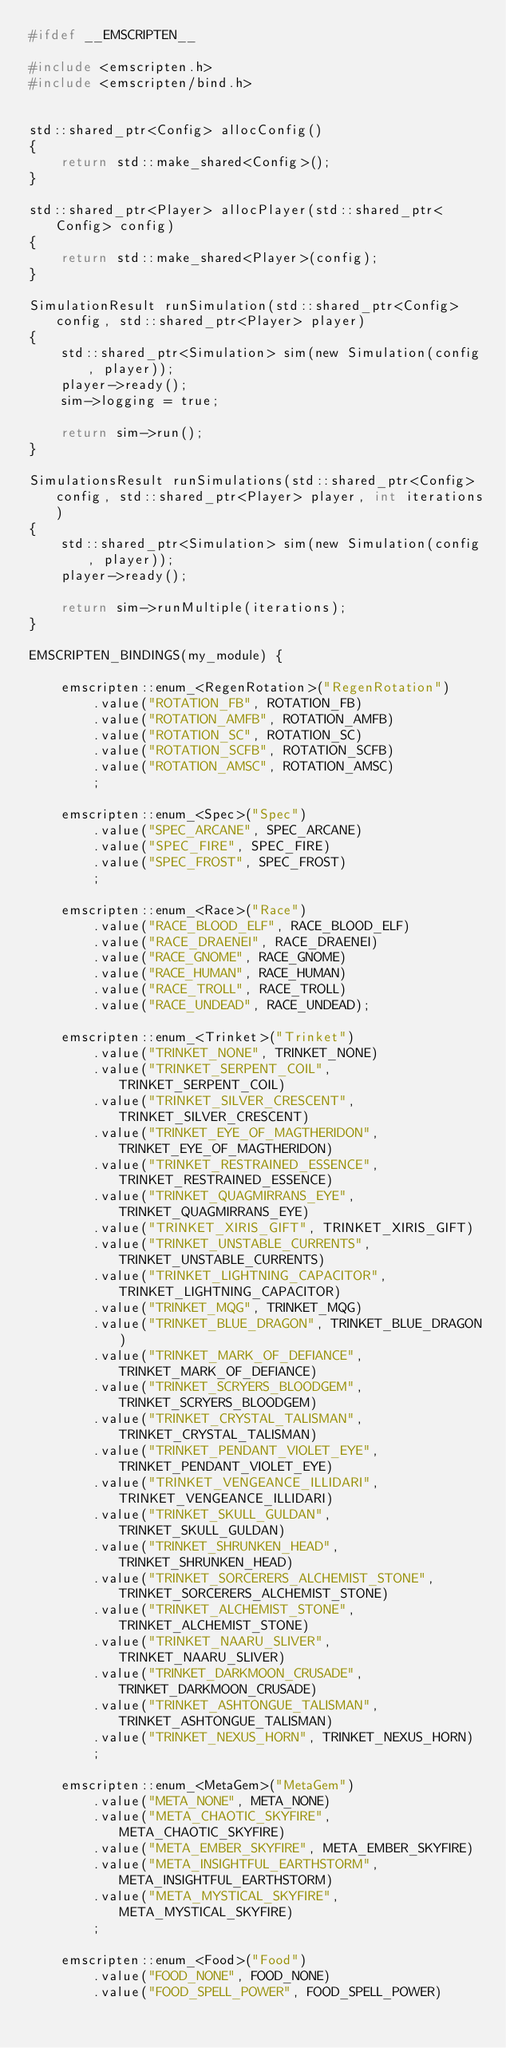<code> <loc_0><loc_0><loc_500><loc_500><_C_>#ifdef __EMSCRIPTEN__

#include <emscripten.h>
#include <emscripten/bind.h>


std::shared_ptr<Config> allocConfig()
{
    return std::make_shared<Config>();
}

std::shared_ptr<Player> allocPlayer(std::shared_ptr<Config> config)
{
    return std::make_shared<Player>(config);
}

SimulationResult runSimulation(std::shared_ptr<Config> config, std::shared_ptr<Player> player)
{
    std::shared_ptr<Simulation> sim(new Simulation(config, player));
    player->ready();
    sim->logging = true;

    return sim->run();
}

SimulationsResult runSimulations(std::shared_ptr<Config> config, std::shared_ptr<Player> player, int iterations)
{
    std::shared_ptr<Simulation> sim(new Simulation(config, player));
    player->ready();

    return sim->runMultiple(iterations);
}

EMSCRIPTEN_BINDINGS(my_module) {

    emscripten::enum_<RegenRotation>("RegenRotation")
        .value("ROTATION_FB", ROTATION_FB)
        .value("ROTATION_AMFB", ROTATION_AMFB)
        .value("ROTATION_SC", ROTATION_SC)
        .value("ROTATION_SCFB", ROTATION_SCFB)
        .value("ROTATION_AMSC", ROTATION_AMSC)
        ;

    emscripten::enum_<Spec>("Spec")
        .value("SPEC_ARCANE", SPEC_ARCANE)
        .value("SPEC_FIRE", SPEC_FIRE)
        .value("SPEC_FROST", SPEC_FROST)
        ;

    emscripten::enum_<Race>("Race")
        .value("RACE_BLOOD_ELF", RACE_BLOOD_ELF)
        .value("RACE_DRAENEI", RACE_DRAENEI)
        .value("RACE_GNOME", RACE_GNOME)
        .value("RACE_HUMAN", RACE_HUMAN)
        .value("RACE_TROLL", RACE_TROLL)
        .value("RACE_UNDEAD", RACE_UNDEAD);

    emscripten::enum_<Trinket>("Trinket")
        .value("TRINKET_NONE", TRINKET_NONE)
        .value("TRINKET_SERPENT_COIL", TRINKET_SERPENT_COIL)
        .value("TRINKET_SILVER_CRESCENT", TRINKET_SILVER_CRESCENT)
        .value("TRINKET_EYE_OF_MAGTHERIDON", TRINKET_EYE_OF_MAGTHERIDON)
        .value("TRINKET_RESTRAINED_ESSENCE", TRINKET_RESTRAINED_ESSENCE)
        .value("TRINKET_QUAGMIRRANS_EYE", TRINKET_QUAGMIRRANS_EYE)
        .value("TRINKET_XIRIS_GIFT", TRINKET_XIRIS_GIFT)
        .value("TRINKET_UNSTABLE_CURRENTS", TRINKET_UNSTABLE_CURRENTS)
        .value("TRINKET_LIGHTNING_CAPACITOR", TRINKET_LIGHTNING_CAPACITOR)
        .value("TRINKET_MQG", TRINKET_MQG)
        .value("TRINKET_BLUE_DRAGON", TRINKET_BLUE_DRAGON)
        .value("TRINKET_MARK_OF_DEFIANCE", TRINKET_MARK_OF_DEFIANCE)
        .value("TRINKET_SCRYERS_BLOODGEM", TRINKET_SCRYERS_BLOODGEM)
        .value("TRINKET_CRYSTAL_TALISMAN", TRINKET_CRYSTAL_TALISMAN)
        .value("TRINKET_PENDANT_VIOLET_EYE", TRINKET_PENDANT_VIOLET_EYE)
        .value("TRINKET_VENGEANCE_ILLIDARI", TRINKET_VENGEANCE_ILLIDARI)
        .value("TRINKET_SKULL_GULDAN", TRINKET_SKULL_GULDAN)
        .value("TRINKET_SHRUNKEN_HEAD", TRINKET_SHRUNKEN_HEAD)
        .value("TRINKET_SORCERERS_ALCHEMIST_STONE", TRINKET_SORCERERS_ALCHEMIST_STONE)
        .value("TRINKET_ALCHEMIST_STONE", TRINKET_ALCHEMIST_STONE)
        .value("TRINKET_NAARU_SLIVER", TRINKET_NAARU_SLIVER)
        .value("TRINKET_DARKMOON_CRUSADE", TRINKET_DARKMOON_CRUSADE)
        .value("TRINKET_ASHTONGUE_TALISMAN", TRINKET_ASHTONGUE_TALISMAN)
        .value("TRINKET_NEXUS_HORN", TRINKET_NEXUS_HORN)
        ;

    emscripten::enum_<MetaGem>("MetaGem")
        .value("META_NONE", META_NONE)
        .value("META_CHAOTIC_SKYFIRE", META_CHAOTIC_SKYFIRE)
        .value("META_EMBER_SKYFIRE", META_EMBER_SKYFIRE)
        .value("META_INSIGHTFUL_EARTHSTORM", META_INSIGHTFUL_EARTHSTORM)
        .value("META_MYSTICAL_SKYFIRE", META_MYSTICAL_SKYFIRE)
        ;

    emscripten::enum_<Food>("Food")
        .value("FOOD_NONE", FOOD_NONE)
        .value("FOOD_SPELL_POWER", FOOD_SPELL_POWER)</code> 